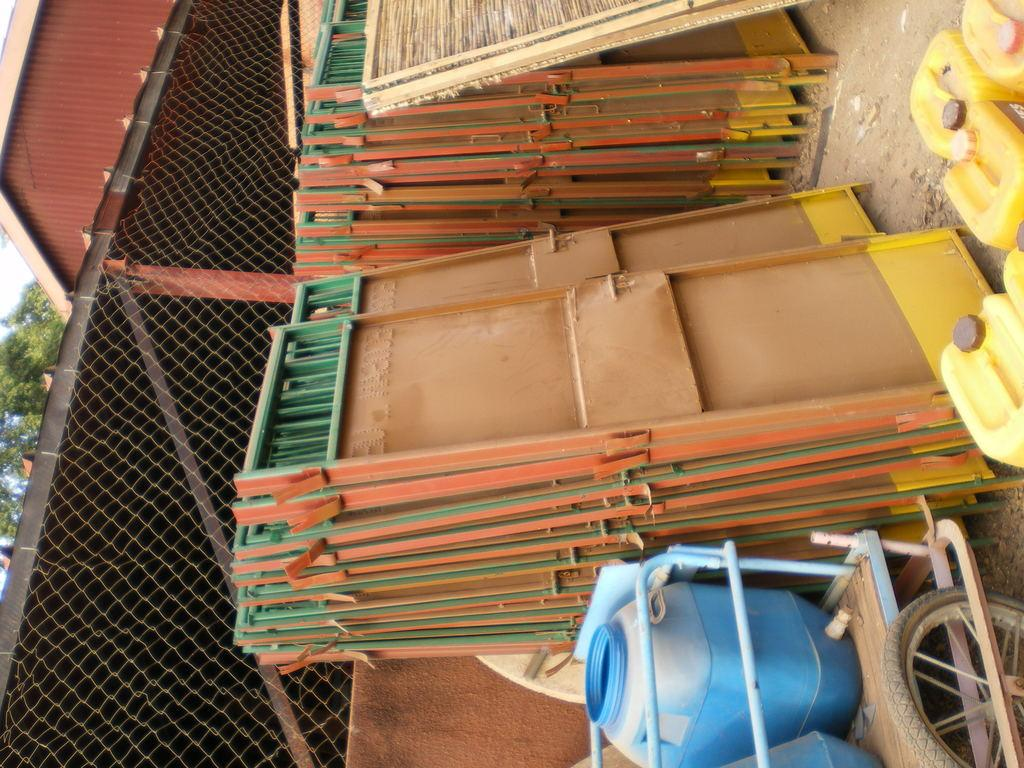What is the main object in the image? There is a cart in the image. What type of objects can be found inside the cart? There are plastic objects in the cart. What structures are present in the image? There are gates and a mesh in the image. What type of vegetation is visible in the image? There is a tree in the image. What part of the natural environment is visible in the image? The sky is visible in the image. What other item can be seen in the image? There is a tire in the image. What type of stew is being prepared in the image? There is no stew present in the image; it features a cart with plastic objects, gates, a mesh, a tree, the sky, and a tire. How much shade is provided by the tree in the image? There is no shade provided by the tree in the image, as it is not the focus of the image and its coverage is not mentioned in the provided facts. 